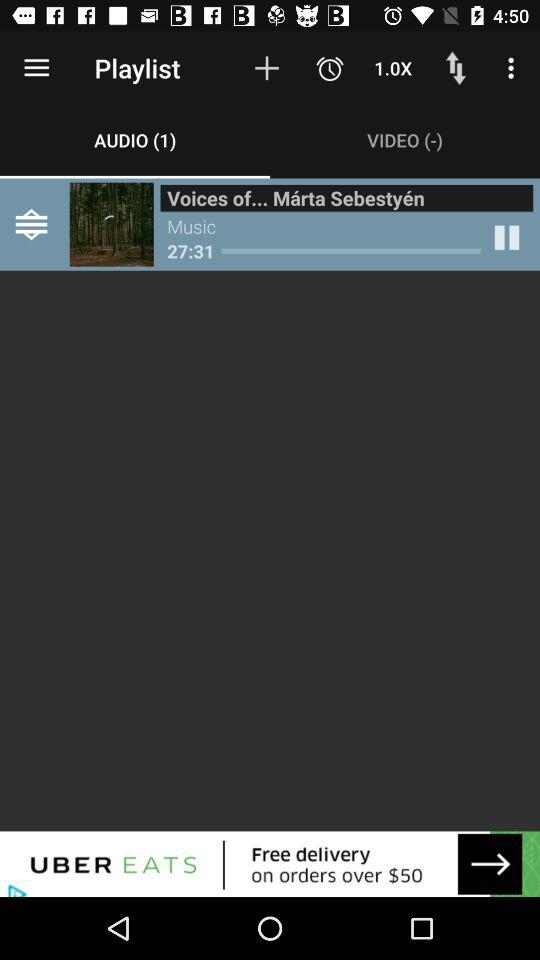Which tab am I on? You are on the "PODCASTS (50)" tab. 